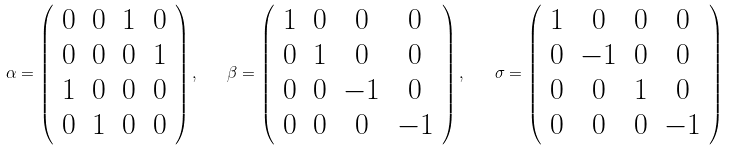<formula> <loc_0><loc_0><loc_500><loc_500>\alpha = \left ( \begin{array} { c c c c } 0 & 0 & 1 & 0 \\ 0 & 0 & 0 & 1 \\ 1 & 0 & 0 & 0 \\ 0 & 1 & 0 & 0 \end{array} \right ) , \quad \beta = \left ( \begin{array} { c c c c } 1 & 0 & 0 & 0 \\ 0 & 1 & 0 & 0 \\ 0 & 0 & - 1 & 0 \\ 0 & 0 & 0 & - 1 \end{array} \right ) , \quad \sigma = \left ( \begin{array} { c c c c } 1 & 0 & 0 & 0 \\ 0 & - 1 & 0 & 0 \\ 0 & 0 & 1 & 0 \\ 0 & 0 & 0 & - 1 \end{array} \right )</formula> 